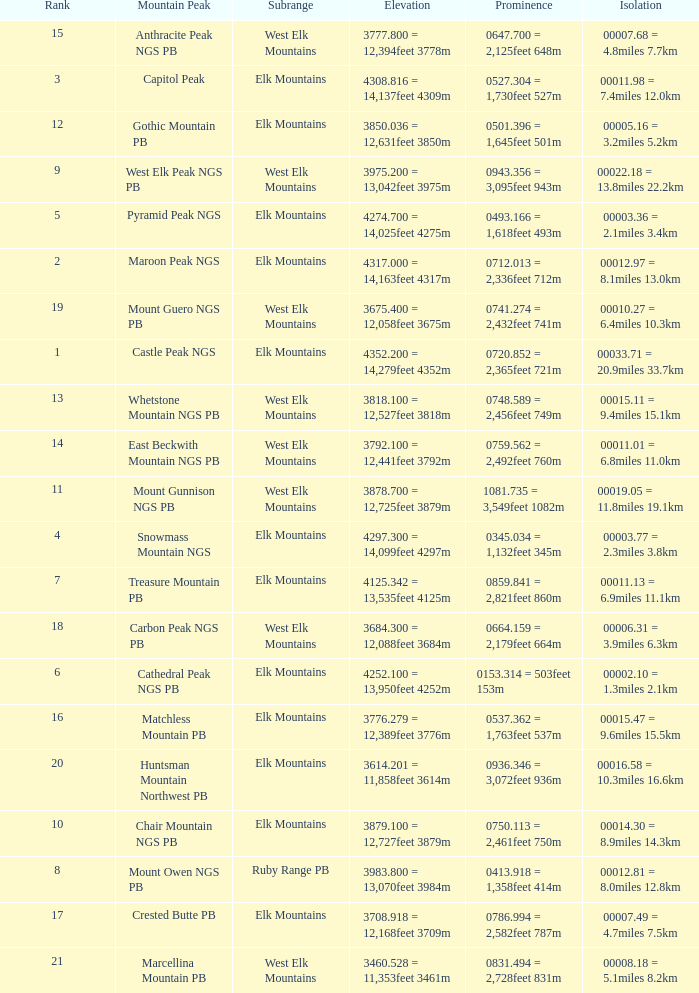Name the Prominence of the Mountain Peak of matchless mountain pb? 0537.362 = 1,763feet 537m. 